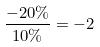<formula> <loc_0><loc_0><loc_500><loc_500>\frac { - 2 0 \% } { 1 0 \% } = - 2</formula> 